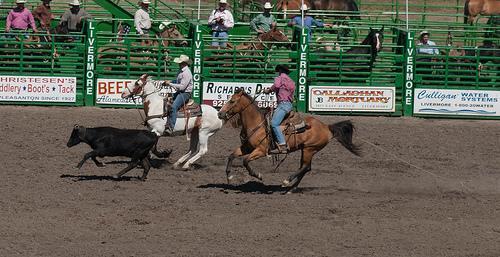How many horses are there?
Give a very brief answer. 2. How many horses are in the picture?
Give a very brief answer. 3. 